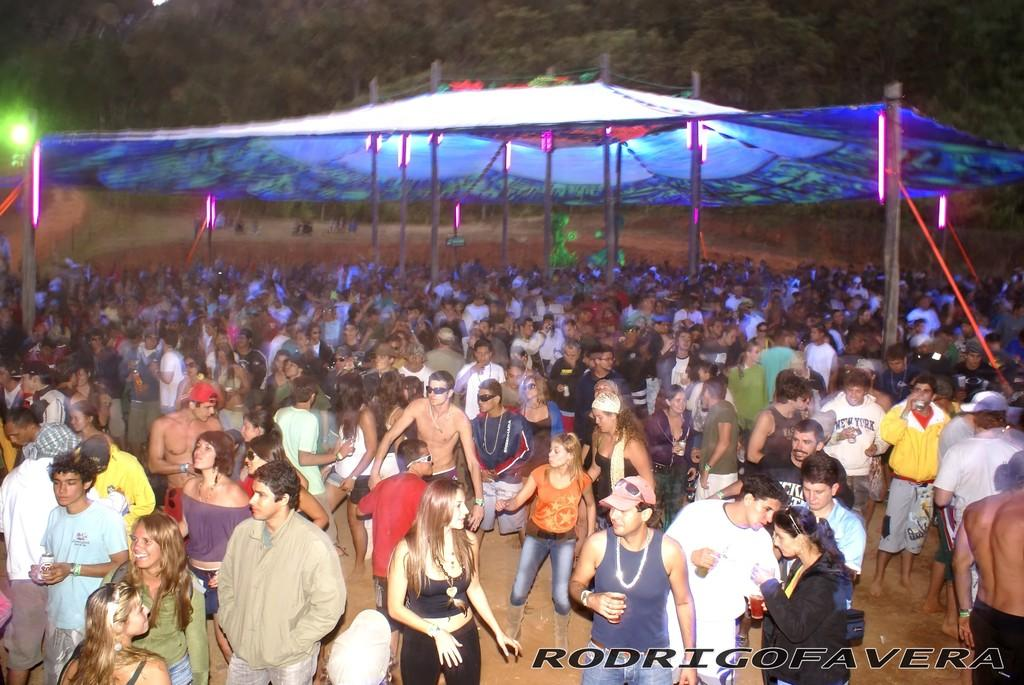What are the people in the image doing? The people are standing under a tent. What feature of the tent is mentioned in the facts? There are lights attached to the tent poles. What can be seen in the background of the image? There are trees in the background of the image. What does the caption say about the winter scene in the image? There is no caption present in the image, and it does not depict a winter scene. 